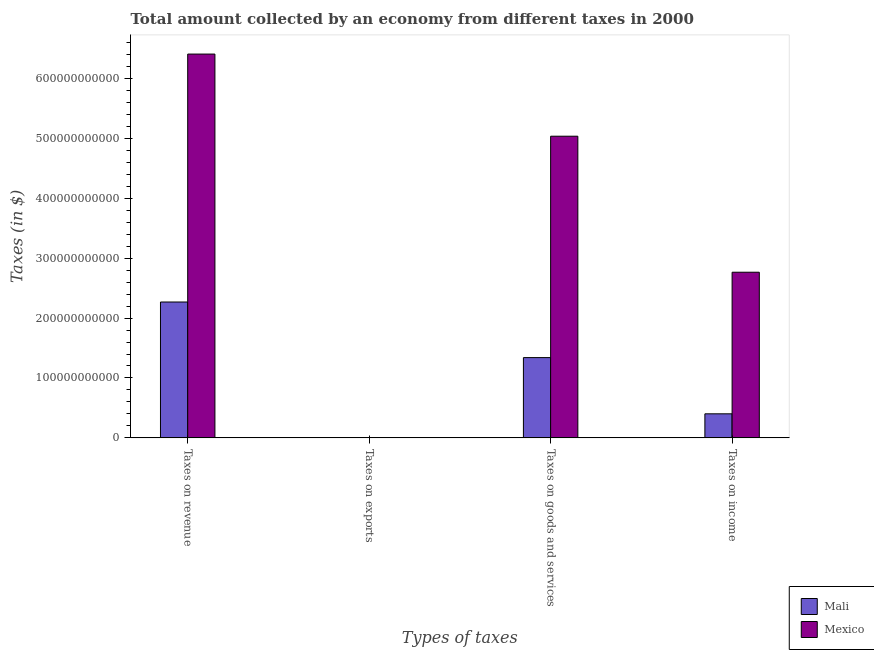How many different coloured bars are there?
Give a very brief answer. 2. How many groups of bars are there?
Provide a succinct answer. 4. Are the number of bars on each tick of the X-axis equal?
Your response must be concise. Yes. What is the label of the 1st group of bars from the left?
Offer a very short reply. Taxes on revenue. What is the amount collected as tax on income in Mexico?
Give a very brief answer. 2.77e+11. Across all countries, what is the maximum amount collected as tax on revenue?
Keep it short and to the point. 6.41e+11. Across all countries, what is the minimum amount collected as tax on exports?
Your answer should be very brief. 2.89e+05. In which country was the amount collected as tax on revenue maximum?
Your answer should be very brief. Mexico. In which country was the amount collected as tax on goods minimum?
Keep it short and to the point. Mali. What is the total amount collected as tax on income in the graph?
Ensure brevity in your answer.  3.17e+11. What is the difference between the amount collected as tax on goods in Mali and that in Mexico?
Your answer should be very brief. -3.70e+11. What is the difference between the amount collected as tax on income in Mali and the amount collected as tax on goods in Mexico?
Offer a very short reply. -4.63e+11. What is the average amount collected as tax on revenue per country?
Provide a short and direct response. 4.34e+11. What is the difference between the amount collected as tax on revenue and amount collected as tax on income in Mali?
Your answer should be very brief. 1.87e+11. What is the ratio of the amount collected as tax on income in Mali to that in Mexico?
Your answer should be very brief. 0.15. Is the amount collected as tax on revenue in Mexico less than that in Mali?
Keep it short and to the point. No. Is the difference between the amount collected as tax on exports in Mali and Mexico greater than the difference between the amount collected as tax on goods in Mali and Mexico?
Provide a short and direct response. Yes. What is the difference between the highest and the second highest amount collected as tax on goods?
Make the answer very short. 3.70e+11. What is the difference between the highest and the lowest amount collected as tax on revenue?
Offer a very short reply. 4.14e+11. In how many countries, is the amount collected as tax on income greater than the average amount collected as tax on income taken over all countries?
Give a very brief answer. 1. Is the sum of the amount collected as tax on income in Mali and Mexico greater than the maximum amount collected as tax on goods across all countries?
Keep it short and to the point. No. Is it the case that in every country, the sum of the amount collected as tax on revenue and amount collected as tax on goods is greater than the sum of amount collected as tax on income and amount collected as tax on exports?
Offer a terse response. No. What does the 2nd bar from the left in Taxes on income represents?
Ensure brevity in your answer.  Mexico. What does the 1st bar from the right in Taxes on exports represents?
Ensure brevity in your answer.  Mexico. Is it the case that in every country, the sum of the amount collected as tax on revenue and amount collected as tax on exports is greater than the amount collected as tax on goods?
Offer a very short reply. Yes. How many bars are there?
Your response must be concise. 8. How many countries are there in the graph?
Your answer should be compact. 2. What is the difference between two consecutive major ticks on the Y-axis?
Offer a very short reply. 1.00e+11. Are the values on the major ticks of Y-axis written in scientific E-notation?
Make the answer very short. No. How many legend labels are there?
Provide a short and direct response. 2. What is the title of the graph?
Make the answer very short. Total amount collected by an economy from different taxes in 2000. Does "High income: nonOECD" appear as one of the legend labels in the graph?
Give a very brief answer. No. What is the label or title of the X-axis?
Offer a very short reply. Types of taxes. What is the label or title of the Y-axis?
Provide a short and direct response. Taxes (in $). What is the Taxes (in $) of Mali in Taxes on revenue?
Provide a succinct answer. 2.27e+11. What is the Taxes (in $) of Mexico in Taxes on revenue?
Offer a very short reply. 6.41e+11. What is the Taxes (in $) in Mali in Taxes on exports?
Your answer should be compact. 2.89e+05. What is the Taxes (in $) in Mexico in Taxes on exports?
Your answer should be compact. 4.00e+06. What is the Taxes (in $) of Mali in Taxes on goods and services?
Provide a succinct answer. 1.34e+11. What is the Taxes (in $) of Mexico in Taxes on goods and services?
Keep it short and to the point. 5.04e+11. What is the Taxes (in $) of Mali in Taxes on income?
Ensure brevity in your answer.  4.01e+1. What is the Taxes (in $) of Mexico in Taxes on income?
Keep it short and to the point. 2.77e+11. Across all Types of taxes, what is the maximum Taxes (in $) in Mali?
Give a very brief answer. 2.27e+11. Across all Types of taxes, what is the maximum Taxes (in $) of Mexico?
Provide a short and direct response. 6.41e+11. Across all Types of taxes, what is the minimum Taxes (in $) in Mali?
Keep it short and to the point. 2.89e+05. What is the total Taxes (in $) in Mali in the graph?
Your answer should be very brief. 4.01e+11. What is the total Taxes (in $) in Mexico in the graph?
Give a very brief answer. 1.42e+12. What is the difference between the Taxes (in $) in Mali in Taxes on revenue and that in Taxes on exports?
Offer a very short reply. 2.27e+11. What is the difference between the Taxes (in $) in Mexico in Taxes on revenue and that in Taxes on exports?
Offer a terse response. 6.41e+11. What is the difference between the Taxes (in $) of Mali in Taxes on revenue and that in Taxes on goods and services?
Your response must be concise. 9.28e+1. What is the difference between the Taxes (in $) in Mexico in Taxes on revenue and that in Taxes on goods and services?
Provide a short and direct response. 1.37e+11. What is the difference between the Taxes (in $) of Mali in Taxes on revenue and that in Taxes on income?
Your answer should be compact. 1.87e+11. What is the difference between the Taxes (in $) of Mexico in Taxes on revenue and that in Taxes on income?
Provide a short and direct response. 3.64e+11. What is the difference between the Taxes (in $) in Mali in Taxes on exports and that in Taxes on goods and services?
Offer a terse response. -1.34e+11. What is the difference between the Taxes (in $) of Mexico in Taxes on exports and that in Taxes on goods and services?
Provide a succinct answer. -5.04e+11. What is the difference between the Taxes (in $) of Mali in Taxes on exports and that in Taxes on income?
Make the answer very short. -4.01e+1. What is the difference between the Taxes (in $) of Mexico in Taxes on exports and that in Taxes on income?
Make the answer very short. -2.77e+11. What is the difference between the Taxes (in $) in Mali in Taxes on goods and services and that in Taxes on income?
Ensure brevity in your answer.  9.39e+1. What is the difference between the Taxes (in $) of Mexico in Taxes on goods and services and that in Taxes on income?
Provide a succinct answer. 2.27e+11. What is the difference between the Taxes (in $) of Mali in Taxes on revenue and the Taxes (in $) of Mexico in Taxes on exports?
Offer a terse response. 2.27e+11. What is the difference between the Taxes (in $) in Mali in Taxes on revenue and the Taxes (in $) in Mexico in Taxes on goods and services?
Keep it short and to the point. -2.77e+11. What is the difference between the Taxes (in $) in Mali in Taxes on revenue and the Taxes (in $) in Mexico in Taxes on income?
Provide a succinct answer. -4.97e+1. What is the difference between the Taxes (in $) in Mali in Taxes on exports and the Taxes (in $) in Mexico in Taxes on goods and services?
Your answer should be very brief. -5.04e+11. What is the difference between the Taxes (in $) of Mali in Taxes on exports and the Taxes (in $) of Mexico in Taxes on income?
Your answer should be very brief. -2.77e+11. What is the difference between the Taxes (in $) in Mali in Taxes on goods and services and the Taxes (in $) in Mexico in Taxes on income?
Provide a succinct answer. -1.43e+11. What is the average Taxes (in $) of Mali per Types of taxes?
Your response must be concise. 1.00e+11. What is the average Taxes (in $) in Mexico per Types of taxes?
Ensure brevity in your answer.  3.55e+11. What is the difference between the Taxes (in $) in Mali and Taxes (in $) in Mexico in Taxes on revenue?
Give a very brief answer. -4.14e+11. What is the difference between the Taxes (in $) of Mali and Taxes (in $) of Mexico in Taxes on exports?
Keep it short and to the point. -3.71e+06. What is the difference between the Taxes (in $) of Mali and Taxes (in $) of Mexico in Taxes on goods and services?
Your answer should be very brief. -3.70e+11. What is the difference between the Taxes (in $) in Mali and Taxes (in $) in Mexico in Taxes on income?
Offer a terse response. -2.36e+11. What is the ratio of the Taxes (in $) in Mali in Taxes on revenue to that in Taxes on exports?
Ensure brevity in your answer.  7.85e+05. What is the ratio of the Taxes (in $) in Mexico in Taxes on revenue to that in Taxes on exports?
Your response must be concise. 1.60e+05. What is the ratio of the Taxes (in $) in Mali in Taxes on revenue to that in Taxes on goods and services?
Offer a terse response. 1.69. What is the ratio of the Taxes (in $) in Mexico in Taxes on revenue to that in Taxes on goods and services?
Provide a short and direct response. 1.27. What is the ratio of the Taxes (in $) in Mali in Taxes on revenue to that in Taxes on income?
Keep it short and to the point. 5.65. What is the ratio of the Taxes (in $) in Mexico in Taxes on revenue to that in Taxes on income?
Provide a short and direct response. 2.32. What is the ratio of the Taxes (in $) in Mexico in Taxes on exports to that in Taxes on goods and services?
Offer a very short reply. 0. What is the ratio of the Taxes (in $) of Mali in Taxes on goods and services to that in Taxes on income?
Provide a succinct answer. 3.34. What is the ratio of the Taxes (in $) in Mexico in Taxes on goods and services to that in Taxes on income?
Give a very brief answer. 1.82. What is the difference between the highest and the second highest Taxes (in $) in Mali?
Your response must be concise. 9.28e+1. What is the difference between the highest and the second highest Taxes (in $) in Mexico?
Your answer should be very brief. 1.37e+11. What is the difference between the highest and the lowest Taxes (in $) in Mali?
Your answer should be very brief. 2.27e+11. What is the difference between the highest and the lowest Taxes (in $) of Mexico?
Ensure brevity in your answer.  6.41e+11. 